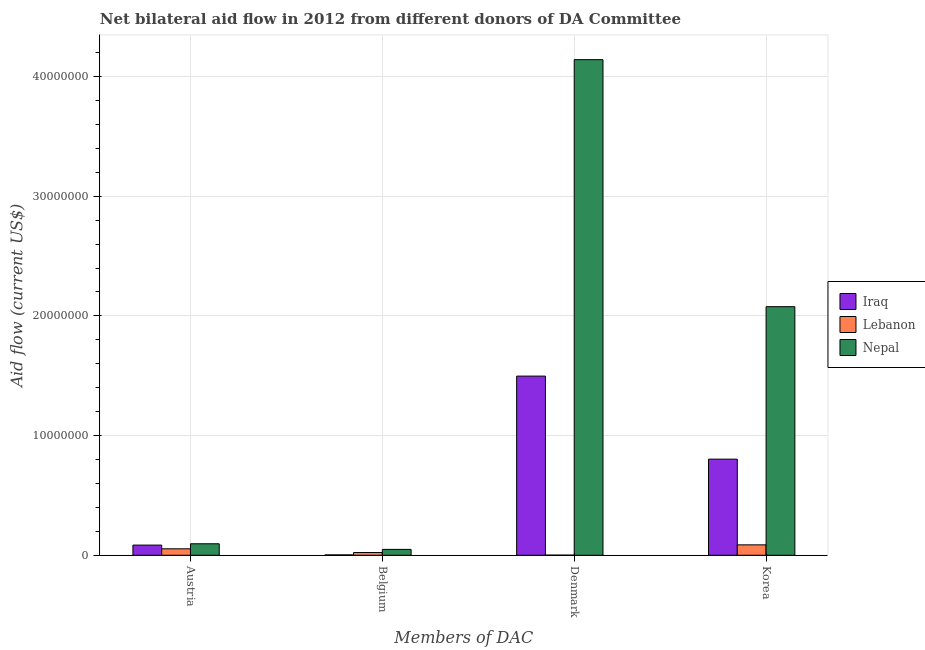How many different coloured bars are there?
Provide a short and direct response. 3. How many groups of bars are there?
Your answer should be compact. 4. Are the number of bars per tick equal to the number of legend labels?
Offer a terse response. Yes. How many bars are there on the 4th tick from the right?
Keep it short and to the point. 3. What is the amount of aid given by korea in Lebanon?
Your answer should be very brief. 8.70e+05. Across all countries, what is the maximum amount of aid given by denmark?
Provide a short and direct response. 4.14e+07. Across all countries, what is the minimum amount of aid given by korea?
Your answer should be very brief. 8.70e+05. In which country was the amount of aid given by denmark maximum?
Provide a short and direct response. Nepal. In which country was the amount of aid given by korea minimum?
Your response must be concise. Lebanon. What is the total amount of aid given by belgium in the graph?
Provide a succinct answer. 7.50e+05. What is the difference between the amount of aid given by denmark in Lebanon and that in Iraq?
Your answer should be very brief. -1.50e+07. What is the difference between the amount of aid given by korea in Lebanon and the amount of aid given by austria in Iraq?
Give a very brief answer. 2.00e+04. What is the difference between the amount of aid given by austria and amount of aid given by denmark in Lebanon?
Offer a terse response. 5.30e+05. In how many countries, is the amount of aid given by denmark greater than 40000000 US$?
Keep it short and to the point. 1. What is the ratio of the amount of aid given by belgium in Lebanon to that in Iraq?
Make the answer very short. 7.67. Is the amount of aid given by korea in Iraq less than that in Nepal?
Make the answer very short. Yes. Is the difference between the amount of aid given by korea in Lebanon and Nepal greater than the difference between the amount of aid given by austria in Lebanon and Nepal?
Your response must be concise. No. What is the difference between the highest and the lowest amount of aid given by denmark?
Your answer should be compact. 4.14e+07. Is the sum of the amount of aid given by denmark in Iraq and Nepal greater than the maximum amount of aid given by belgium across all countries?
Make the answer very short. Yes. What does the 1st bar from the left in Korea represents?
Provide a succinct answer. Iraq. What does the 3rd bar from the right in Korea represents?
Provide a short and direct response. Iraq. Is it the case that in every country, the sum of the amount of aid given by austria and amount of aid given by belgium is greater than the amount of aid given by denmark?
Provide a succinct answer. No. How many bars are there?
Offer a very short reply. 12. Does the graph contain any zero values?
Give a very brief answer. No. Does the graph contain grids?
Offer a very short reply. Yes. How many legend labels are there?
Provide a succinct answer. 3. What is the title of the graph?
Offer a terse response. Net bilateral aid flow in 2012 from different donors of DA Committee. Does "Afghanistan" appear as one of the legend labels in the graph?
Give a very brief answer. No. What is the label or title of the X-axis?
Your answer should be very brief. Members of DAC. What is the label or title of the Y-axis?
Give a very brief answer. Aid flow (current US$). What is the Aid flow (current US$) in Iraq in Austria?
Provide a short and direct response. 8.50e+05. What is the Aid flow (current US$) of Lebanon in Austria?
Keep it short and to the point. 5.40e+05. What is the Aid flow (current US$) in Nepal in Austria?
Keep it short and to the point. 9.60e+05. What is the Aid flow (current US$) of Lebanon in Belgium?
Provide a succinct answer. 2.30e+05. What is the Aid flow (current US$) of Iraq in Denmark?
Your response must be concise. 1.50e+07. What is the Aid flow (current US$) in Nepal in Denmark?
Your response must be concise. 4.14e+07. What is the Aid flow (current US$) in Iraq in Korea?
Your answer should be very brief. 8.03e+06. What is the Aid flow (current US$) of Lebanon in Korea?
Your answer should be very brief. 8.70e+05. What is the Aid flow (current US$) in Nepal in Korea?
Offer a terse response. 2.08e+07. Across all Members of DAC, what is the maximum Aid flow (current US$) in Iraq?
Make the answer very short. 1.50e+07. Across all Members of DAC, what is the maximum Aid flow (current US$) of Lebanon?
Provide a short and direct response. 8.70e+05. Across all Members of DAC, what is the maximum Aid flow (current US$) of Nepal?
Ensure brevity in your answer.  4.14e+07. Across all Members of DAC, what is the minimum Aid flow (current US$) of Nepal?
Provide a succinct answer. 4.90e+05. What is the total Aid flow (current US$) of Iraq in the graph?
Your response must be concise. 2.39e+07. What is the total Aid flow (current US$) in Lebanon in the graph?
Give a very brief answer. 1.65e+06. What is the total Aid flow (current US$) in Nepal in the graph?
Your response must be concise. 6.36e+07. What is the difference between the Aid flow (current US$) of Iraq in Austria and that in Belgium?
Provide a short and direct response. 8.20e+05. What is the difference between the Aid flow (current US$) of Lebanon in Austria and that in Belgium?
Offer a terse response. 3.10e+05. What is the difference between the Aid flow (current US$) in Nepal in Austria and that in Belgium?
Make the answer very short. 4.70e+05. What is the difference between the Aid flow (current US$) in Iraq in Austria and that in Denmark?
Make the answer very short. -1.41e+07. What is the difference between the Aid flow (current US$) of Lebanon in Austria and that in Denmark?
Your answer should be very brief. 5.30e+05. What is the difference between the Aid flow (current US$) in Nepal in Austria and that in Denmark?
Offer a terse response. -4.04e+07. What is the difference between the Aid flow (current US$) in Iraq in Austria and that in Korea?
Offer a terse response. -7.18e+06. What is the difference between the Aid flow (current US$) in Lebanon in Austria and that in Korea?
Offer a very short reply. -3.30e+05. What is the difference between the Aid flow (current US$) in Nepal in Austria and that in Korea?
Provide a succinct answer. -1.98e+07. What is the difference between the Aid flow (current US$) in Iraq in Belgium and that in Denmark?
Your answer should be compact. -1.49e+07. What is the difference between the Aid flow (current US$) in Nepal in Belgium and that in Denmark?
Ensure brevity in your answer.  -4.09e+07. What is the difference between the Aid flow (current US$) of Iraq in Belgium and that in Korea?
Your answer should be very brief. -8.00e+06. What is the difference between the Aid flow (current US$) in Lebanon in Belgium and that in Korea?
Provide a succinct answer. -6.40e+05. What is the difference between the Aid flow (current US$) in Nepal in Belgium and that in Korea?
Keep it short and to the point. -2.03e+07. What is the difference between the Aid flow (current US$) in Iraq in Denmark and that in Korea?
Your answer should be very brief. 6.94e+06. What is the difference between the Aid flow (current US$) of Lebanon in Denmark and that in Korea?
Give a very brief answer. -8.60e+05. What is the difference between the Aid flow (current US$) in Nepal in Denmark and that in Korea?
Provide a short and direct response. 2.06e+07. What is the difference between the Aid flow (current US$) of Iraq in Austria and the Aid flow (current US$) of Lebanon in Belgium?
Make the answer very short. 6.20e+05. What is the difference between the Aid flow (current US$) in Iraq in Austria and the Aid flow (current US$) in Nepal in Belgium?
Keep it short and to the point. 3.60e+05. What is the difference between the Aid flow (current US$) of Iraq in Austria and the Aid flow (current US$) of Lebanon in Denmark?
Your answer should be very brief. 8.40e+05. What is the difference between the Aid flow (current US$) of Iraq in Austria and the Aid flow (current US$) of Nepal in Denmark?
Provide a short and direct response. -4.06e+07. What is the difference between the Aid flow (current US$) in Lebanon in Austria and the Aid flow (current US$) in Nepal in Denmark?
Offer a very short reply. -4.09e+07. What is the difference between the Aid flow (current US$) in Iraq in Austria and the Aid flow (current US$) in Nepal in Korea?
Make the answer very short. -1.99e+07. What is the difference between the Aid flow (current US$) in Lebanon in Austria and the Aid flow (current US$) in Nepal in Korea?
Provide a short and direct response. -2.02e+07. What is the difference between the Aid flow (current US$) of Iraq in Belgium and the Aid flow (current US$) of Lebanon in Denmark?
Make the answer very short. 2.00e+04. What is the difference between the Aid flow (current US$) of Iraq in Belgium and the Aid flow (current US$) of Nepal in Denmark?
Provide a short and direct response. -4.14e+07. What is the difference between the Aid flow (current US$) of Lebanon in Belgium and the Aid flow (current US$) of Nepal in Denmark?
Keep it short and to the point. -4.12e+07. What is the difference between the Aid flow (current US$) in Iraq in Belgium and the Aid flow (current US$) in Lebanon in Korea?
Give a very brief answer. -8.40e+05. What is the difference between the Aid flow (current US$) in Iraq in Belgium and the Aid flow (current US$) in Nepal in Korea?
Provide a succinct answer. -2.07e+07. What is the difference between the Aid flow (current US$) of Lebanon in Belgium and the Aid flow (current US$) of Nepal in Korea?
Your answer should be very brief. -2.05e+07. What is the difference between the Aid flow (current US$) of Iraq in Denmark and the Aid flow (current US$) of Lebanon in Korea?
Keep it short and to the point. 1.41e+07. What is the difference between the Aid flow (current US$) of Iraq in Denmark and the Aid flow (current US$) of Nepal in Korea?
Ensure brevity in your answer.  -5.80e+06. What is the difference between the Aid flow (current US$) in Lebanon in Denmark and the Aid flow (current US$) in Nepal in Korea?
Give a very brief answer. -2.08e+07. What is the average Aid flow (current US$) of Iraq per Members of DAC?
Provide a short and direct response. 5.97e+06. What is the average Aid flow (current US$) in Lebanon per Members of DAC?
Give a very brief answer. 4.12e+05. What is the average Aid flow (current US$) of Nepal per Members of DAC?
Your answer should be very brief. 1.59e+07. What is the difference between the Aid flow (current US$) of Iraq and Aid flow (current US$) of Lebanon in Austria?
Provide a succinct answer. 3.10e+05. What is the difference between the Aid flow (current US$) of Iraq and Aid flow (current US$) of Nepal in Austria?
Your answer should be compact. -1.10e+05. What is the difference between the Aid flow (current US$) in Lebanon and Aid flow (current US$) in Nepal in Austria?
Ensure brevity in your answer.  -4.20e+05. What is the difference between the Aid flow (current US$) in Iraq and Aid flow (current US$) in Nepal in Belgium?
Your answer should be compact. -4.60e+05. What is the difference between the Aid flow (current US$) of Iraq and Aid flow (current US$) of Lebanon in Denmark?
Your answer should be very brief. 1.50e+07. What is the difference between the Aid flow (current US$) in Iraq and Aid flow (current US$) in Nepal in Denmark?
Offer a terse response. -2.64e+07. What is the difference between the Aid flow (current US$) of Lebanon and Aid flow (current US$) of Nepal in Denmark?
Your answer should be very brief. -4.14e+07. What is the difference between the Aid flow (current US$) of Iraq and Aid flow (current US$) of Lebanon in Korea?
Ensure brevity in your answer.  7.16e+06. What is the difference between the Aid flow (current US$) in Iraq and Aid flow (current US$) in Nepal in Korea?
Keep it short and to the point. -1.27e+07. What is the difference between the Aid flow (current US$) of Lebanon and Aid flow (current US$) of Nepal in Korea?
Your answer should be compact. -1.99e+07. What is the ratio of the Aid flow (current US$) in Iraq in Austria to that in Belgium?
Make the answer very short. 28.33. What is the ratio of the Aid flow (current US$) in Lebanon in Austria to that in Belgium?
Offer a very short reply. 2.35. What is the ratio of the Aid flow (current US$) of Nepal in Austria to that in Belgium?
Provide a succinct answer. 1.96. What is the ratio of the Aid flow (current US$) in Iraq in Austria to that in Denmark?
Offer a terse response. 0.06. What is the ratio of the Aid flow (current US$) of Nepal in Austria to that in Denmark?
Offer a very short reply. 0.02. What is the ratio of the Aid flow (current US$) in Iraq in Austria to that in Korea?
Keep it short and to the point. 0.11. What is the ratio of the Aid flow (current US$) in Lebanon in Austria to that in Korea?
Make the answer very short. 0.62. What is the ratio of the Aid flow (current US$) of Nepal in Austria to that in Korea?
Give a very brief answer. 0.05. What is the ratio of the Aid flow (current US$) in Iraq in Belgium to that in Denmark?
Provide a succinct answer. 0. What is the ratio of the Aid flow (current US$) of Lebanon in Belgium to that in Denmark?
Give a very brief answer. 23. What is the ratio of the Aid flow (current US$) of Nepal in Belgium to that in Denmark?
Your response must be concise. 0.01. What is the ratio of the Aid flow (current US$) in Iraq in Belgium to that in Korea?
Your response must be concise. 0. What is the ratio of the Aid flow (current US$) of Lebanon in Belgium to that in Korea?
Make the answer very short. 0.26. What is the ratio of the Aid flow (current US$) of Nepal in Belgium to that in Korea?
Provide a short and direct response. 0.02. What is the ratio of the Aid flow (current US$) in Iraq in Denmark to that in Korea?
Your answer should be compact. 1.86. What is the ratio of the Aid flow (current US$) of Lebanon in Denmark to that in Korea?
Make the answer very short. 0.01. What is the ratio of the Aid flow (current US$) in Nepal in Denmark to that in Korea?
Make the answer very short. 1.99. What is the difference between the highest and the second highest Aid flow (current US$) of Iraq?
Keep it short and to the point. 6.94e+06. What is the difference between the highest and the second highest Aid flow (current US$) in Lebanon?
Make the answer very short. 3.30e+05. What is the difference between the highest and the second highest Aid flow (current US$) of Nepal?
Offer a terse response. 2.06e+07. What is the difference between the highest and the lowest Aid flow (current US$) of Iraq?
Make the answer very short. 1.49e+07. What is the difference between the highest and the lowest Aid flow (current US$) in Lebanon?
Make the answer very short. 8.60e+05. What is the difference between the highest and the lowest Aid flow (current US$) in Nepal?
Your response must be concise. 4.09e+07. 